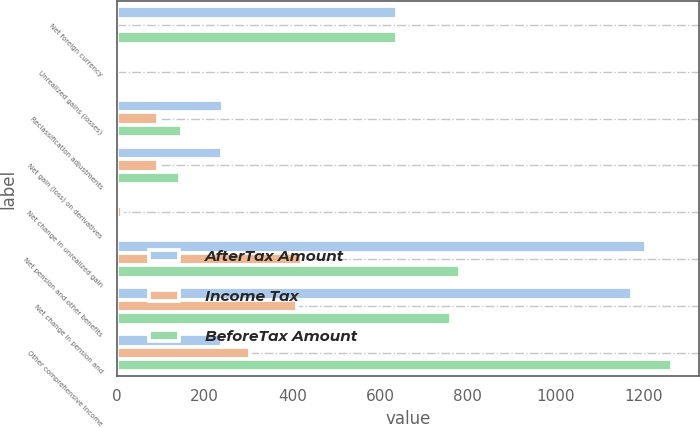<chart> <loc_0><loc_0><loc_500><loc_500><stacked_bar_chart><ecel><fcel>Net foreign currency<fcel>Unrealized gains (losses)<fcel>Reclassification adjustments<fcel>Net gain (loss) on derivatives<fcel>Net change in unrealized gain<fcel>Net pension and other benefits<fcel>Net change in pension and<fcel>Other comprehensive income<nl><fcel>AfterTax Amount<fcel>639<fcel>3<fcel>243<fcel>240<fcel>6<fcel>1206<fcel>1175<fcel>240<nl><fcel>Income Tax<fcel>1<fcel>1<fcel>94<fcel>95<fcel>13<fcel>423<fcel>412<fcel>303<nl><fcel>BeforeTax Amount<fcel>640<fcel>4<fcel>149<fcel>145<fcel>7<fcel>783<fcel>763<fcel>1265<nl></chart> 